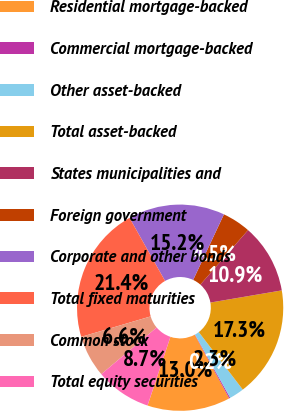Convert chart. <chart><loc_0><loc_0><loc_500><loc_500><pie_chart><fcel>Residential mortgage-backed<fcel>Commercial mortgage-backed<fcel>Other asset-backed<fcel>Total asset-backed<fcel>States municipalities and<fcel>Foreign government<fcel>Corporate and other bonds<fcel>Total fixed maturities<fcel>Common stock<fcel>Total equity securities<nl><fcel>13.01%<fcel>0.18%<fcel>2.32%<fcel>17.29%<fcel>10.87%<fcel>4.46%<fcel>15.15%<fcel>21.39%<fcel>6.59%<fcel>8.73%<nl></chart> 